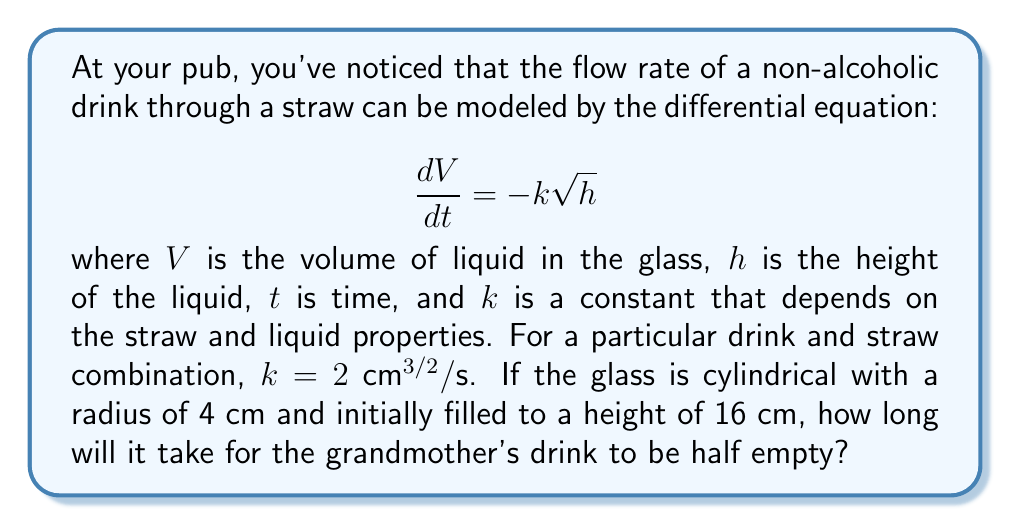Show me your answer to this math problem. Let's approach this step-by-step:

1) First, we need to relate the volume $V$ to the height $h$. For a cylindrical glass:
   
   $V = \pi r^2 h$

   where $r$ is the radius of the glass.

2) Differentiating both sides with respect to $t$:

   $$\frac{dV}{dt} = \pi r^2 \frac{dh}{dt}$$

3) Substituting this into our original differential equation:

   $$\pi r^2 \frac{dh}{dt} = -k\sqrt{h}$$

4) Rearranging:

   $$\frac{dh}{dt} = -\frac{k}{\pi r^2}\sqrt{h}$$

5) This is a separable differential equation. Let's separate and integrate:

   $$\int_{h_0}^{h} \frac{dh}{\sqrt{h}} = -\frac{k}{\pi r^2}\int_0^t dt$$

   where $h_0$ is the initial height.

6) Solving the integrals:

   $$2\sqrt{h} - 2\sqrt{h_0} = -\frac{k}{\pi r^2}t$$

7) Solving for $t$:

   $$t = \frac{2\pi r^2}{k}(\sqrt{h_0} - \sqrt{h})$$

8) We want to find when the drink is half empty. This means the height will be half of the initial height:

   $h = \frac{h_0}{2} = 8$ cm

9) Plugging in our values ($k = 2$ cm^(3/2)/s, $r = 4$ cm, $h_0 = 16$ cm, $h = 8$ cm):

   $$t = \frac{2\pi (4^2)}{2}(\sqrt{16} - \sqrt{8})$$

10) Simplifying:

    $$t = 16\pi(4 - 2\sqrt{2}) \approx 47.1$$
Answer: It will take approximately 47.1 seconds for the grandmother's drink to be half empty. 